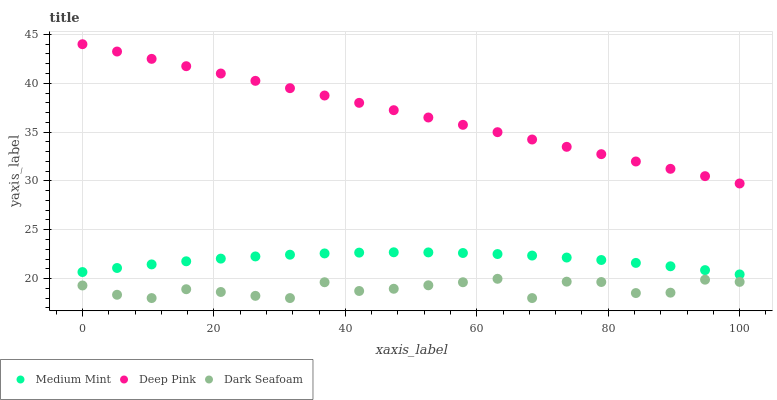Does Dark Seafoam have the minimum area under the curve?
Answer yes or no. Yes. Does Deep Pink have the maximum area under the curve?
Answer yes or no. Yes. Does Deep Pink have the minimum area under the curve?
Answer yes or no. No. Does Dark Seafoam have the maximum area under the curve?
Answer yes or no. No. Is Deep Pink the smoothest?
Answer yes or no. Yes. Is Dark Seafoam the roughest?
Answer yes or no. Yes. Is Dark Seafoam the smoothest?
Answer yes or no. No. Is Deep Pink the roughest?
Answer yes or no. No. Does Dark Seafoam have the lowest value?
Answer yes or no. Yes. Does Deep Pink have the lowest value?
Answer yes or no. No. Does Deep Pink have the highest value?
Answer yes or no. Yes. Does Dark Seafoam have the highest value?
Answer yes or no. No. Is Dark Seafoam less than Medium Mint?
Answer yes or no. Yes. Is Deep Pink greater than Medium Mint?
Answer yes or no. Yes. Does Dark Seafoam intersect Medium Mint?
Answer yes or no. No. 